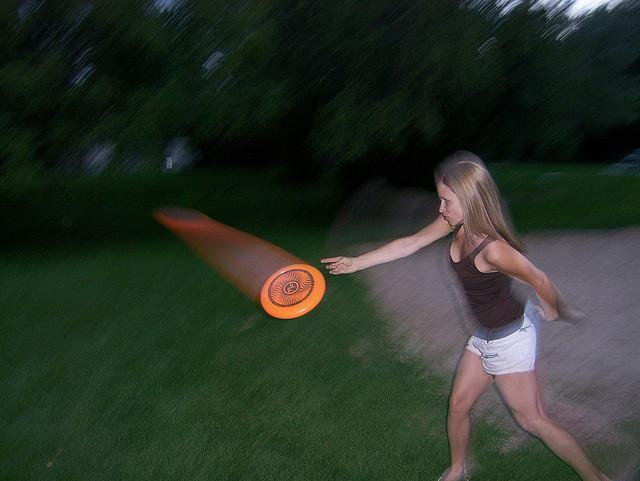How many frisbees are there?
Give a very brief answer. 1. How many red chairs are there?
Give a very brief answer. 0. 